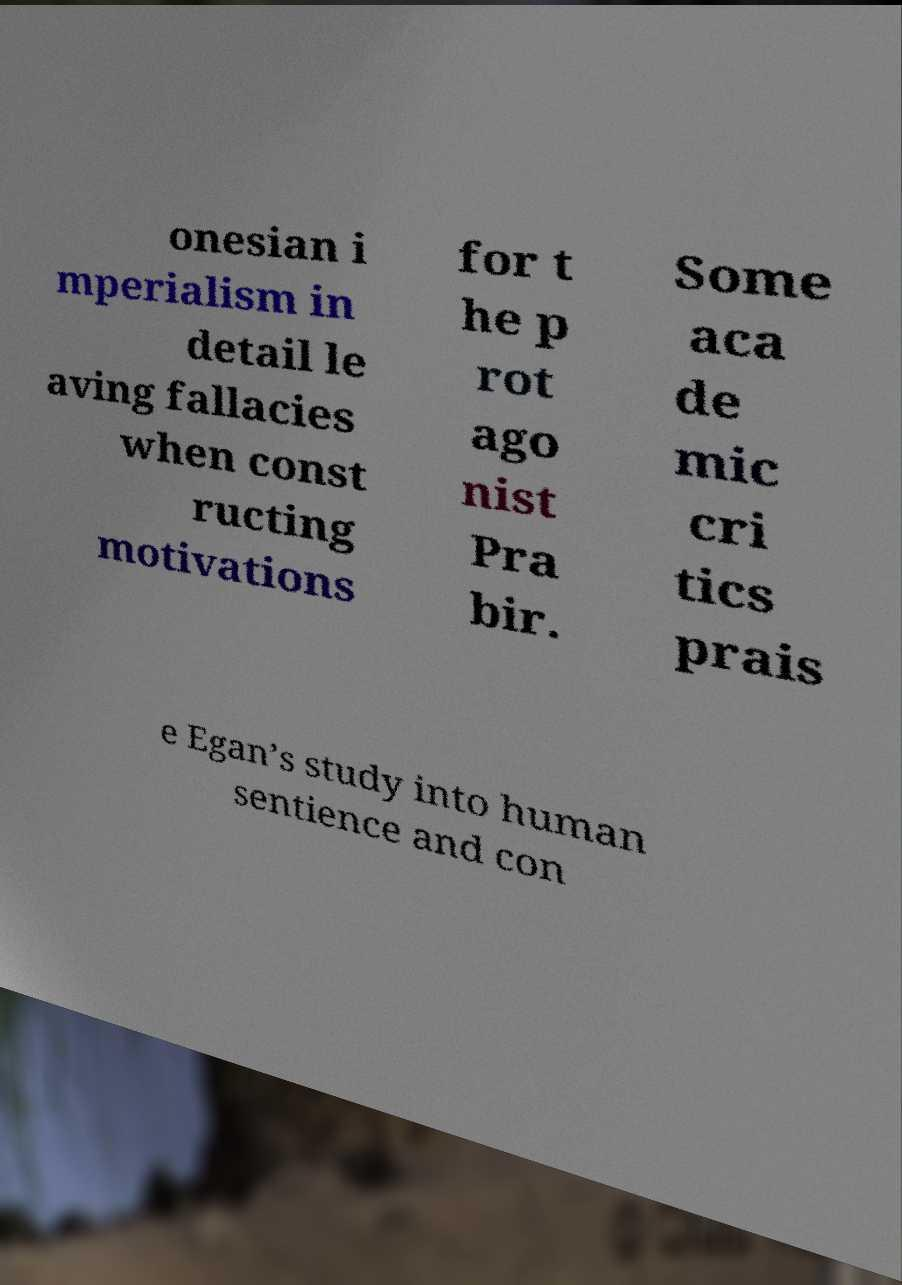Please read and relay the text visible in this image. What does it say? onesian i mperialism in detail le aving fallacies when const ructing motivations for t he p rot ago nist Pra bir. Some aca de mic cri tics prais e Egan’s study into human sentience and con 